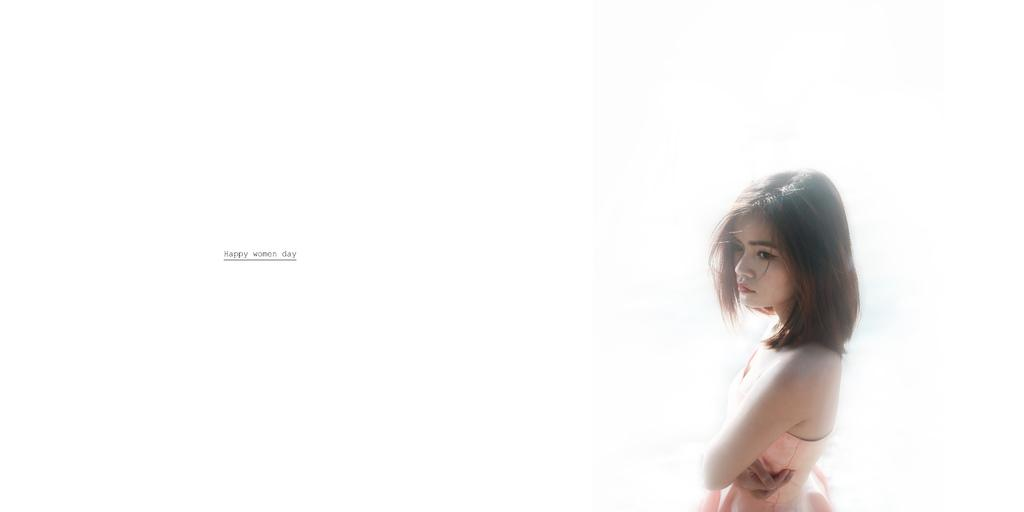Who is the main subject in the image? There is a woman in the image. Where is the woman positioned in the image? The woman is standing on the right side of the image. What else can be seen on the left side of the image? There is text on the left side of the image. How many legs does the paint have in the image? There is no paint present in the image, so it does not have any legs. 